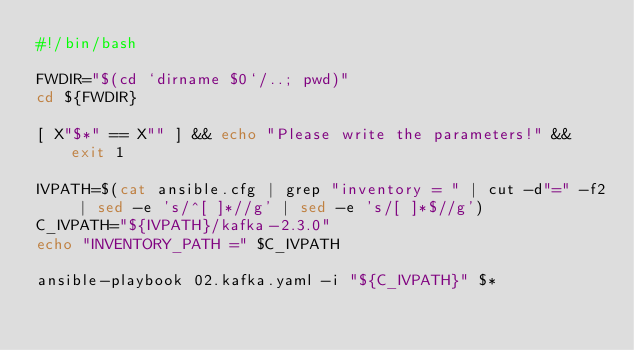<code> <loc_0><loc_0><loc_500><loc_500><_Bash_>#!/bin/bash

FWDIR="$(cd `dirname $0`/..; pwd)"
cd ${FWDIR}

[ X"$*" == X"" ] && echo "Please write the parameters!" && exit 1

IVPATH=$(cat ansible.cfg | grep "inventory = " | cut -d"=" -f2 | sed -e 's/^[ ]*//g' | sed -e 's/[ ]*$//g')
C_IVPATH="${IVPATH}/kafka-2.3.0"
echo "INVENTORY_PATH =" $C_IVPATH

ansible-playbook 02.kafka.yaml -i "${C_IVPATH}" $*
</code> 